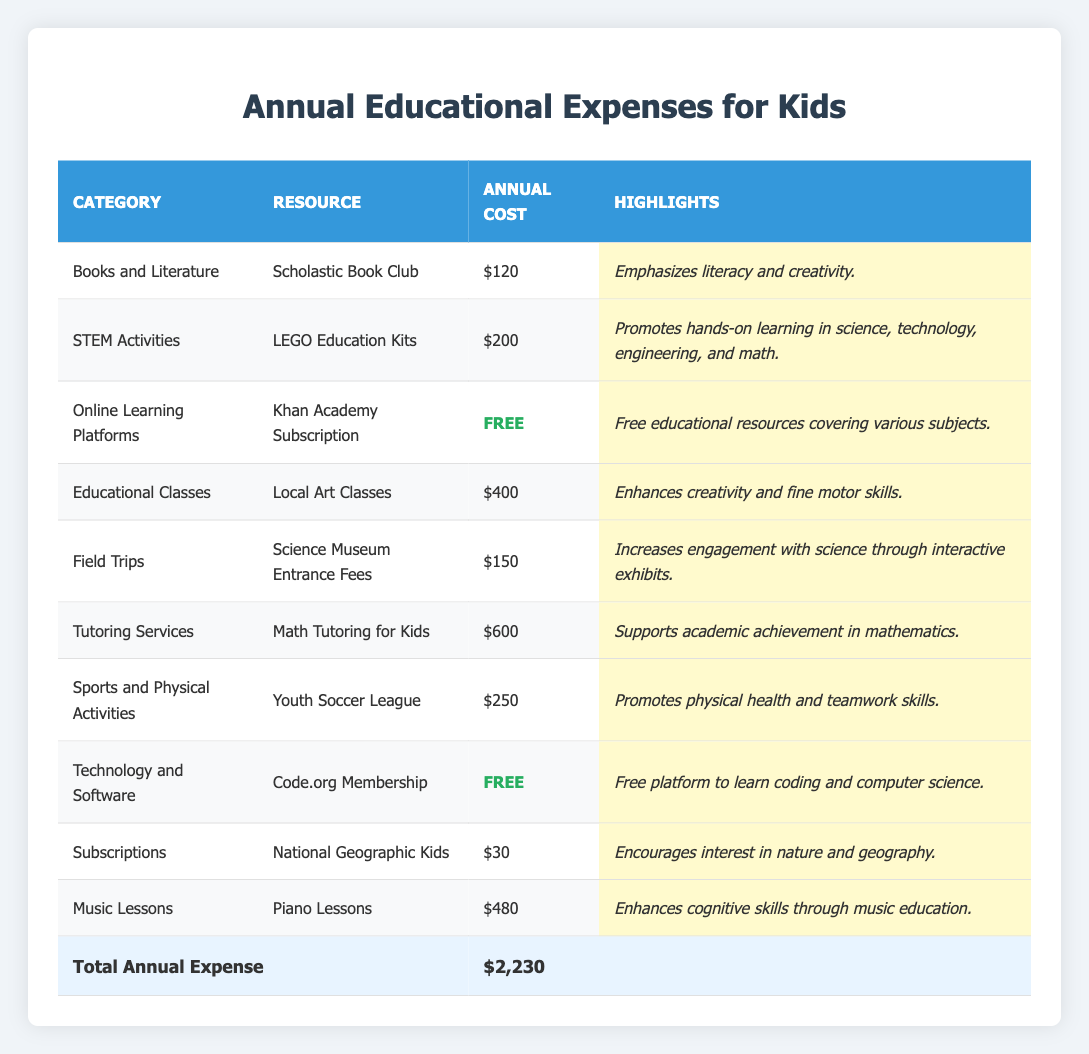What is the total annual expense on educational resources and activities for kids? The table lists a total annual expense in the last row labeled "Total Annual Expense," which shows $2,230.
Answer: $2,230 How much does the Math Tutoring for Kids cost annually? The row indicating "Math Tutoring for Kids" shows an annual cost of $600.
Answer: $600 Is the cost of the Khan Academy Subscription free? The entry for "Khan Academy Subscription" displays "FREE" for its annual cost, confirming that it does not have an associated expense.
Answer: Yes What is the combined cost of the Local Art Classes and the Piano Lessons? The cost of Local Art Classes is $400, and the cost of Piano Lessons is $480. Adding these together gives $400 + $480 = $880.
Answer: $880 Which resource has the highest annual expense? The table shows that the "Math Tutoring for Kids" has the highest cost at $600, compared to other resources.
Answer: Math Tutoring for Kids What is the average annual cost of the resources that incur a fee? The resources with fees are Scholastic Book Club ($120), LEGO Education Kits ($200), Local Art Classes ($400), Science Museum Entrance Fees ($150), Math Tutoring for Kids ($600), Youth Soccer League ($250), Piano Lessons ($480). The total for these is $120 + $200 + $400 + $150 + $600 + $250 + $480 = $2200. There are 7 resources, so the average is $2200 / 7 ≈ $314.29.
Answer: Approximately $314.29 Are there any free resources listed in the table? The entries "Khan Academy Subscription" and "Code.org Membership" both have an annual cost stated as "FREE," indicating these are indeed free resources.
Answer: Yes What is the difference in annual cost between the LEGO Education Kits and the Youth Soccer League? The cost of LEGO Education Kits is $200, and the Youth Soccer League is $250. The difference is calculated as $250 - $200 = $50.
Answer: $50 How many resources have an annual cost of more than $200? The resources with costs over $200 are LEGO Education Kits ($200), Local Art Classes ($400), Math Tutoring for Kids ($600), and Youth Soccer League ($250). This totals to 4 resources.
Answer: 4 If you wanted to minimize expenses, which free resources could you choose? The free resources listed are "Khan Academy Subscription" and "Code.org Membership." Selecting both would incur no costs.
Answer: Khan Academy Subscription and Code.org Membership What percentage of the total annual expense is spent on Music Lessons? The cost of Music Lessons is $480. The total annual expense is $2,230. The percentage is calculated as ($480 / $2,230) * 100 = 21.5%.
Answer: 21.5% 